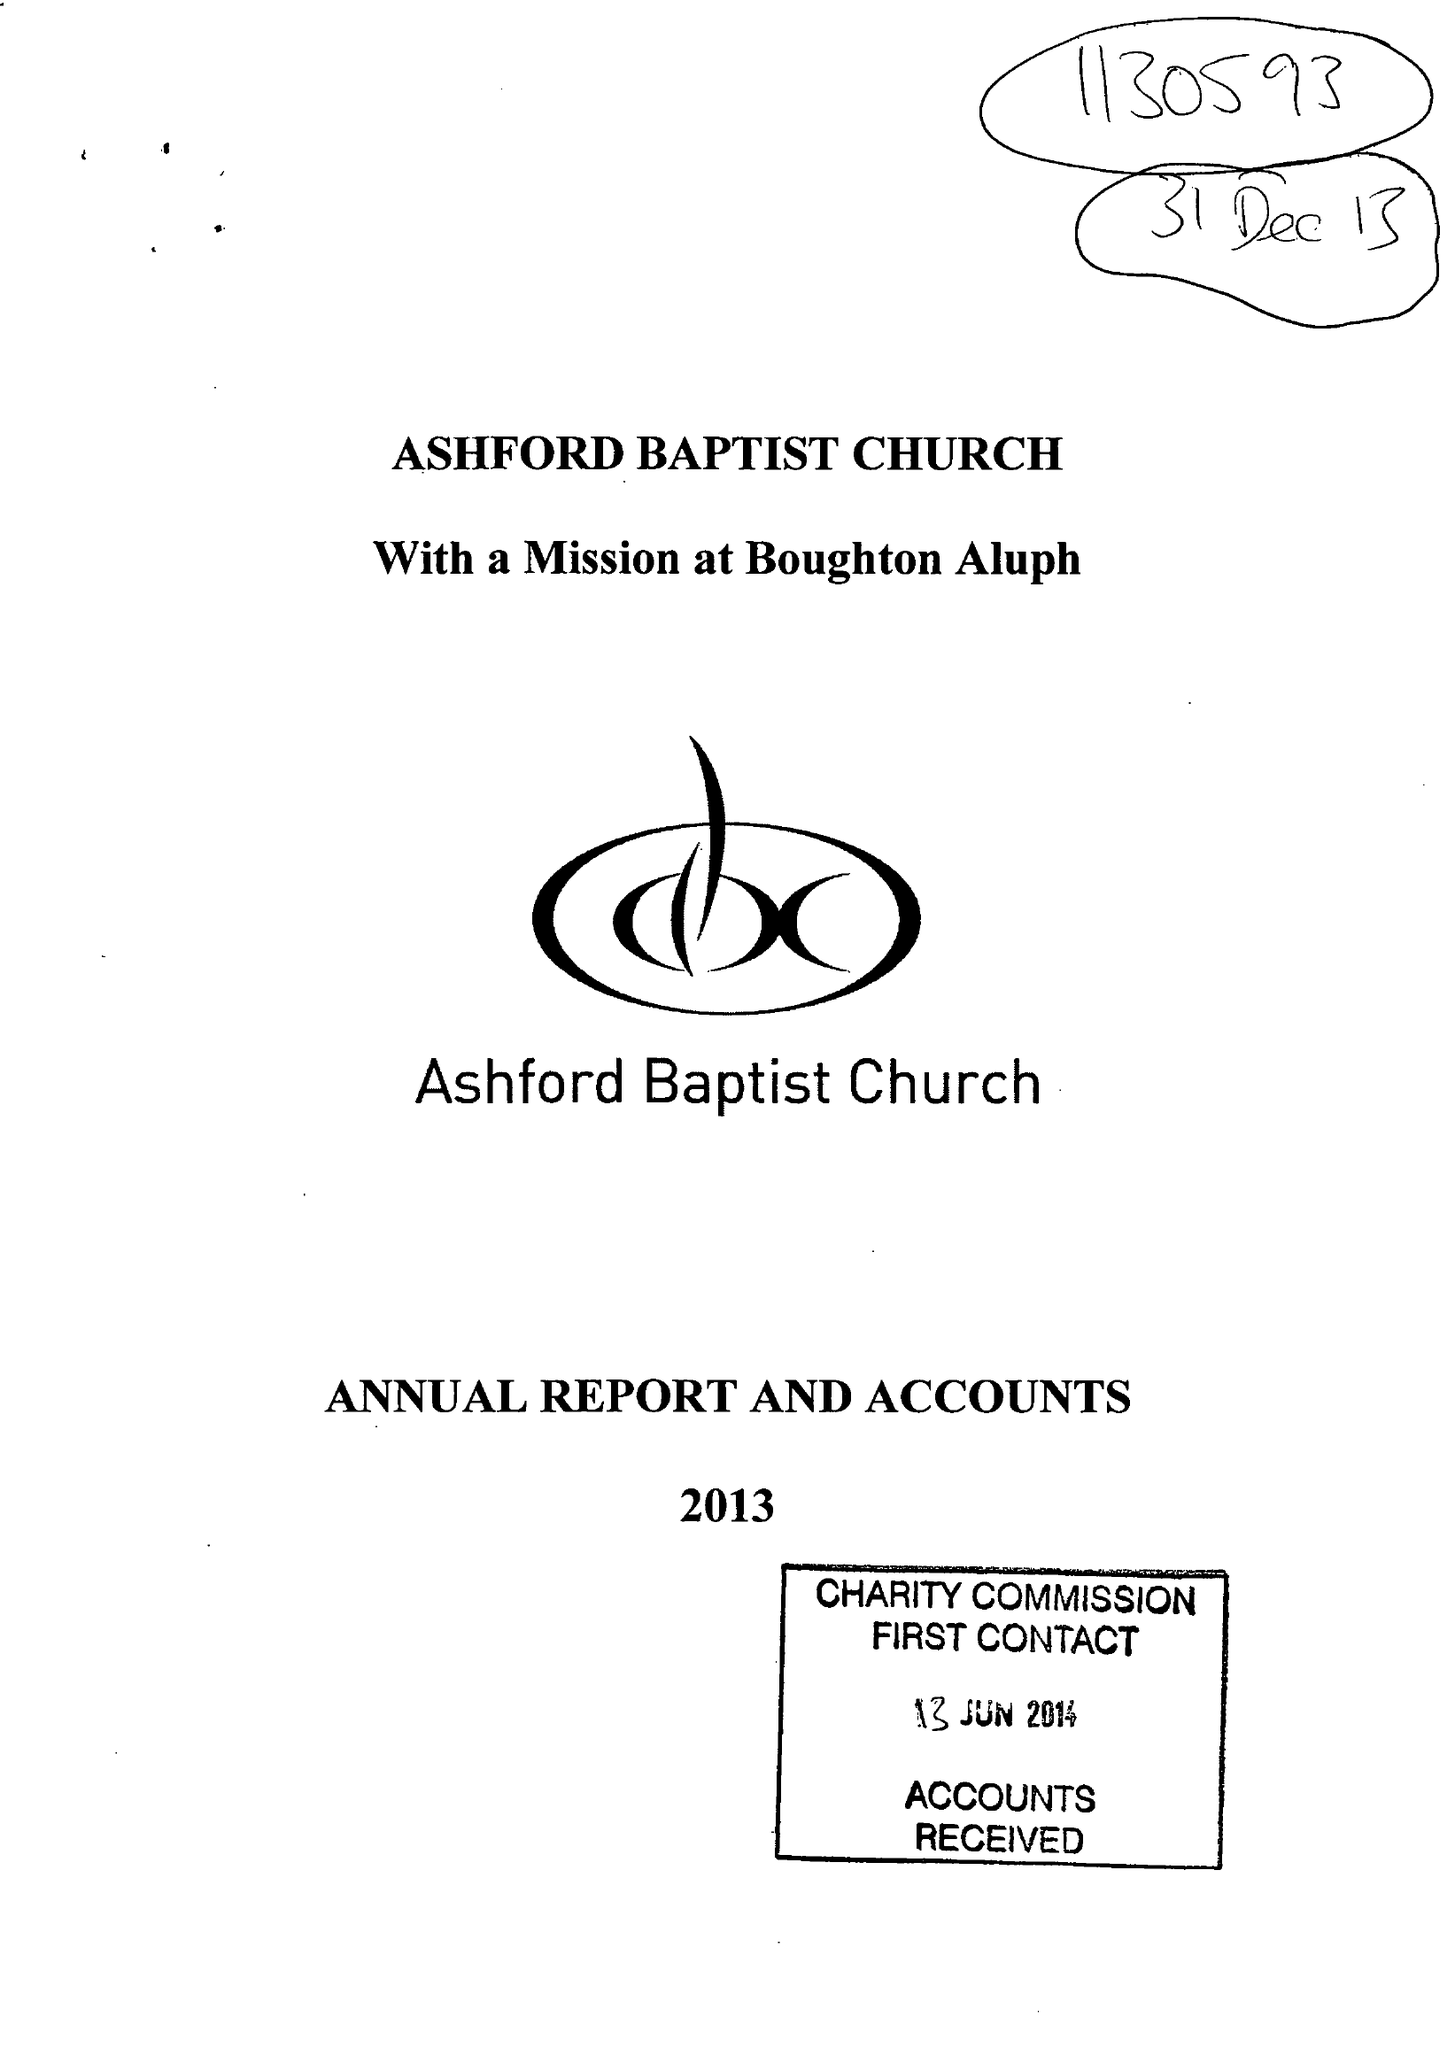What is the value for the charity_name?
Answer the question using a single word or phrase. Ashford Baptist Church 